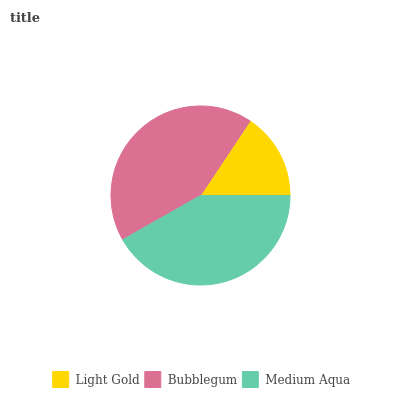Is Light Gold the minimum?
Answer yes or no. Yes. Is Bubblegum the maximum?
Answer yes or no. Yes. Is Medium Aqua the minimum?
Answer yes or no. No. Is Medium Aqua the maximum?
Answer yes or no. No. Is Bubblegum greater than Medium Aqua?
Answer yes or no. Yes. Is Medium Aqua less than Bubblegum?
Answer yes or no. Yes. Is Medium Aqua greater than Bubblegum?
Answer yes or no. No. Is Bubblegum less than Medium Aqua?
Answer yes or no. No. Is Medium Aqua the high median?
Answer yes or no. Yes. Is Medium Aqua the low median?
Answer yes or no. Yes. Is Light Gold the high median?
Answer yes or no. No. Is Bubblegum the low median?
Answer yes or no. No. 